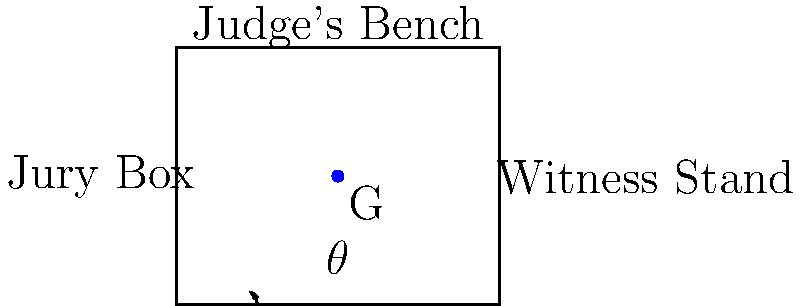In a newly designed courtroom, the optimal viewing angle $\theta$ from the center of the jury box to the witness stand is crucial for fair trials. The courtroom is rectangular, measuring 10 meters wide and 8 meters long. The jury box is centered on the left wall, and the witness stand is on the right wall, both 4 meters from the front of the courtroom where the judge's bench is located. If point G represents the center of the jury box, what is the optimal viewing angle $\theta$ to the witness stand? Let's approach this step-by-step:

1) First, we need to identify the triangle formed by the jury box center (G), the witness stand, and the point directly below the witness stand on the courtroom floor.

2) We can see that this forms a right triangle, where:
   - The base of the triangle is the width of the courtroom (10 meters)
   - The height of the triangle is the distance from the front of the courtroom to G (4 meters)

3) We're looking for the angle $\theta$ at the base of this triangle.

4) In a right triangle, we can use the tangent function to find this angle:

   $$\tan(\theta) = \frac{\text{opposite}}{\text{adjacent}}$$

5) In our case:
   - The opposite side is the height of the triangle (4 meters)
   - The adjacent side is the width of the courtroom (10 meters)

6) Plugging these values into the equation:

   $$\tan(\theta) = \frac{4}{10} = 0.4$$

7) To find $\theta$, we need to take the inverse tangent (arctan or $\tan^{-1}$) of both sides:

   $$\theta = \tan^{-1}(0.4)$$

8) Using a calculator or trigonometric tables, we can determine that:

   $$\theta \approx 21.8^\circ$$

Therefore, the optimal viewing angle from the center of the jury box to the witness stand is approximately 21.8 degrees.
Answer: $21.8^\circ$ 